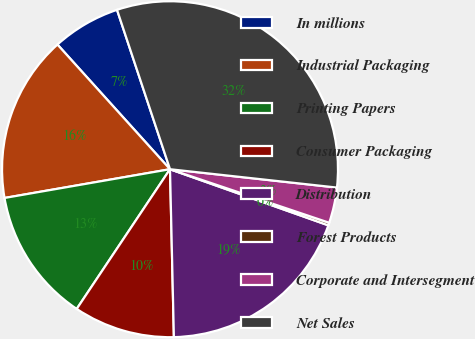Convert chart. <chart><loc_0><loc_0><loc_500><loc_500><pie_chart><fcel>In millions<fcel>Industrial Packaging<fcel>Printing Papers<fcel>Consumer Packaging<fcel>Distribution<fcel>Forest Products<fcel>Corporate and Intersegment<fcel>Net Sales<nl><fcel>6.58%<fcel>16.05%<fcel>12.89%<fcel>9.74%<fcel>19.21%<fcel>0.26%<fcel>3.42%<fcel>31.85%<nl></chart> 